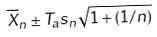<formula> <loc_0><loc_0><loc_500><loc_500>\overline { X } _ { n } \pm T _ { a } s _ { n } \sqrt { 1 + ( 1 / n ) }</formula> 